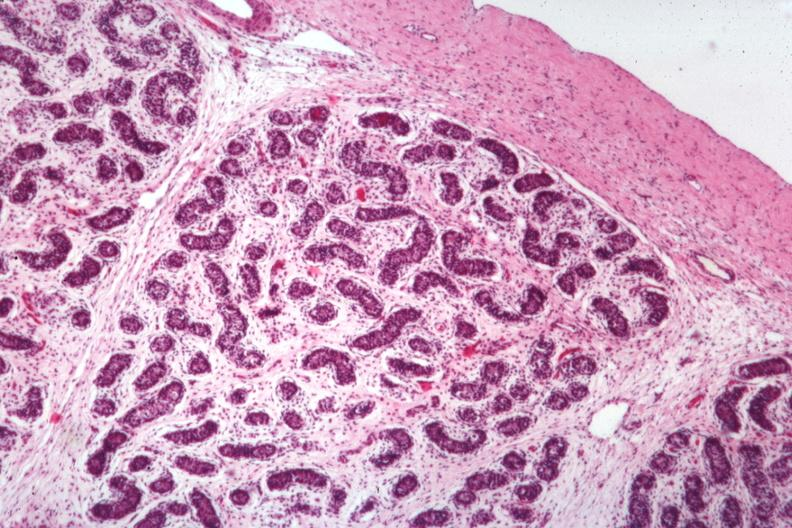s testicle present?
Answer the question using a single word or phrase. Yes 